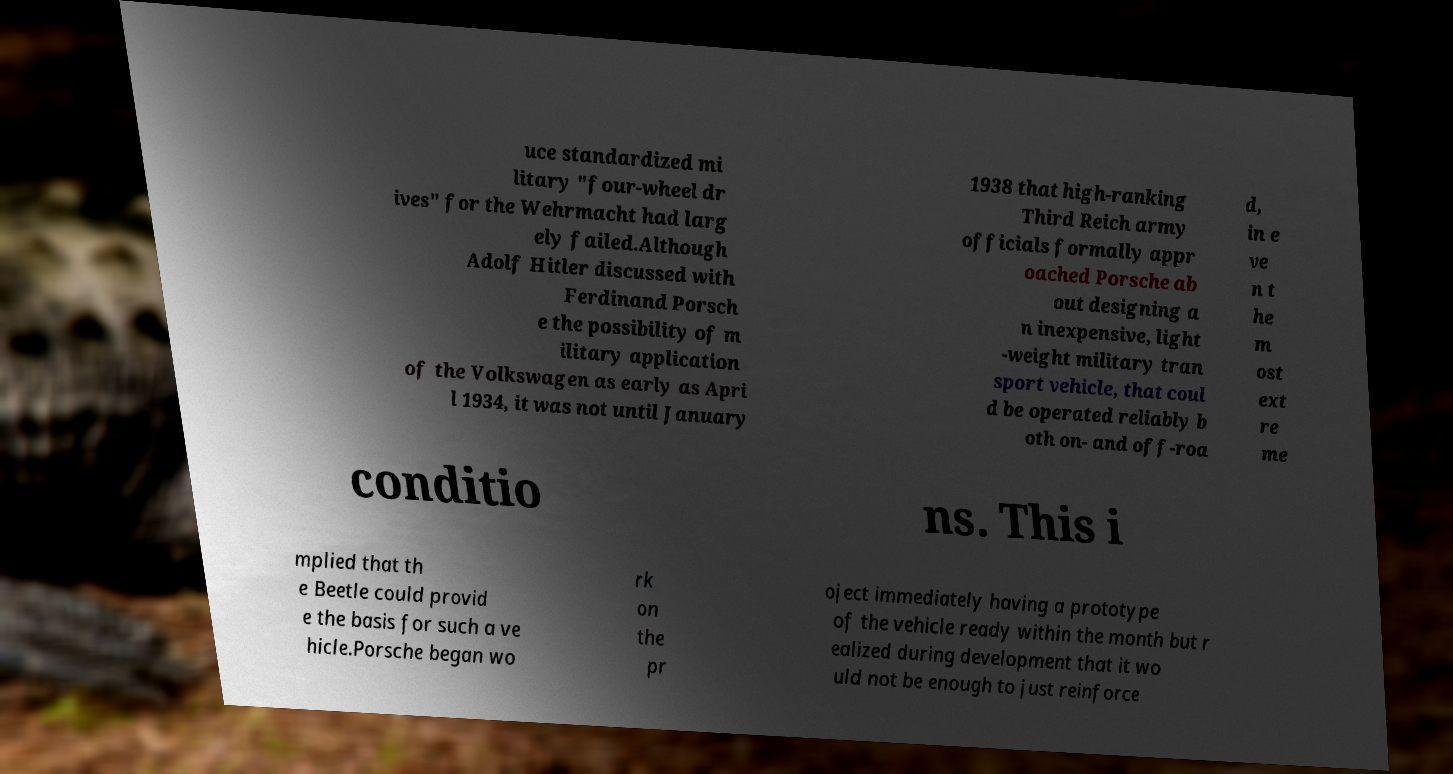Please read and relay the text visible in this image. What does it say? uce standardized mi litary "four-wheel dr ives" for the Wehrmacht had larg ely failed.Although Adolf Hitler discussed with Ferdinand Porsch e the possibility of m ilitary application of the Volkswagen as early as Apri l 1934, it was not until January 1938 that high-ranking Third Reich army officials formally appr oached Porsche ab out designing a n inexpensive, light -weight military tran sport vehicle, that coul d be operated reliably b oth on- and off-roa d, in e ve n t he m ost ext re me conditio ns. This i mplied that th e Beetle could provid e the basis for such a ve hicle.Porsche began wo rk on the pr oject immediately having a prototype of the vehicle ready within the month but r ealized during development that it wo uld not be enough to just reinforce 